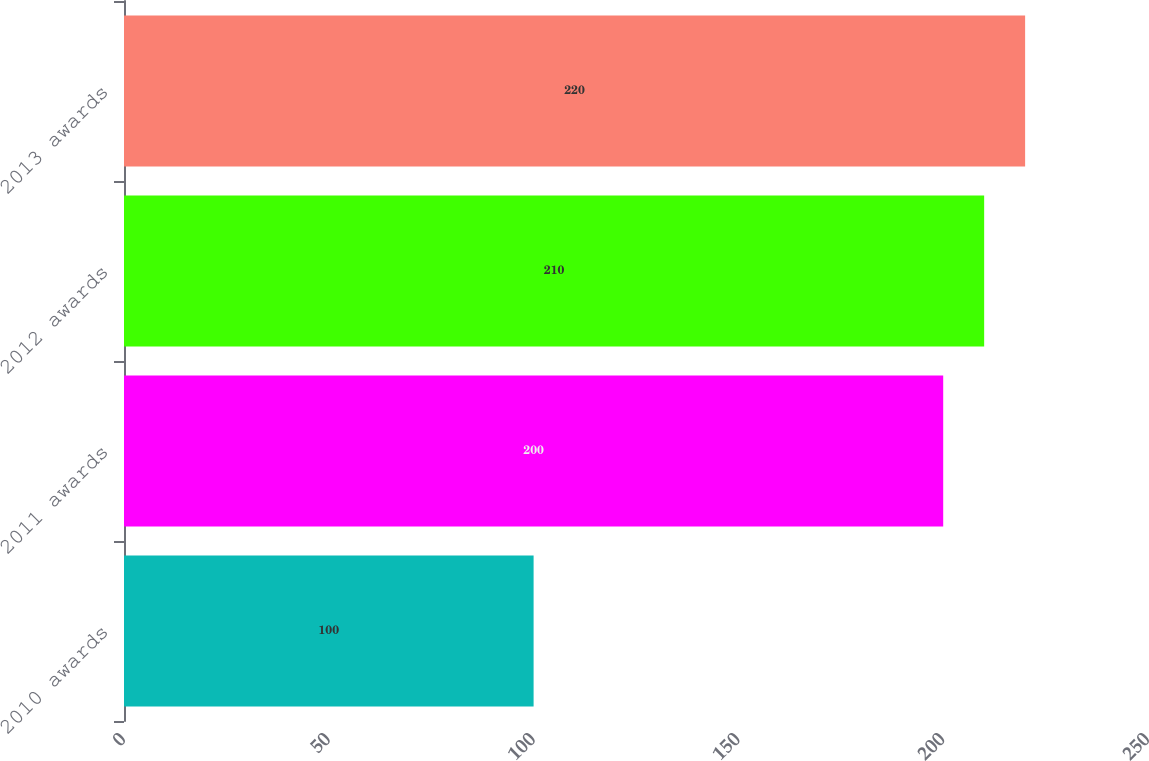Convert chart to OTSL. <chart><loc_0><loc_0><loc_500><loc_500><bar_chart><fcel>2010 awards<fcel>2011 awards<fcel>2012 awards<fcel>2013 awards<nl><fcel>100<fcel>200<fcel>210<fcel>220<nl></chart> 